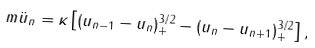<formula> <loc_0><loc_0><loc_500><loc_500>m \ddot { u } _ { n } = \kappa \left [ ( u _ { n - 1 } - u _ { n } ) ^ { 3 / 2 } _ { + } - ( u _ { n } - u _ { n + 1 } ) ^ { 3 / 2 } _ { + } \right ] ,</formula> 